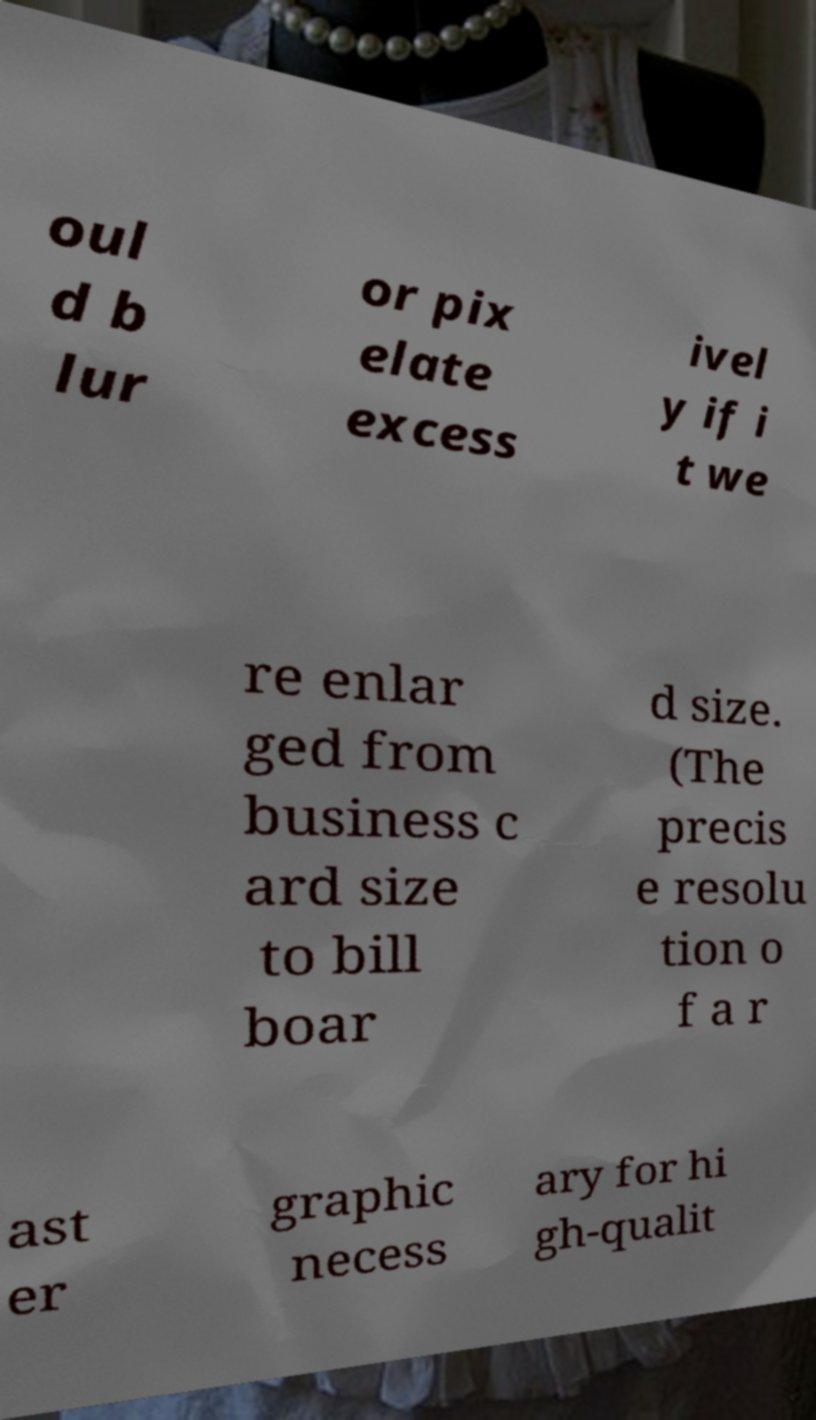For documentation purposes, I need the text within this image transcribed. Could you provide that? oul d b lur or pix elate excess ivel y if i t we re enlar ged from business c ard size to bill boar d size. (The precis e resolu tion o f a r ast er graphic necess ary for hi gh-qualit 